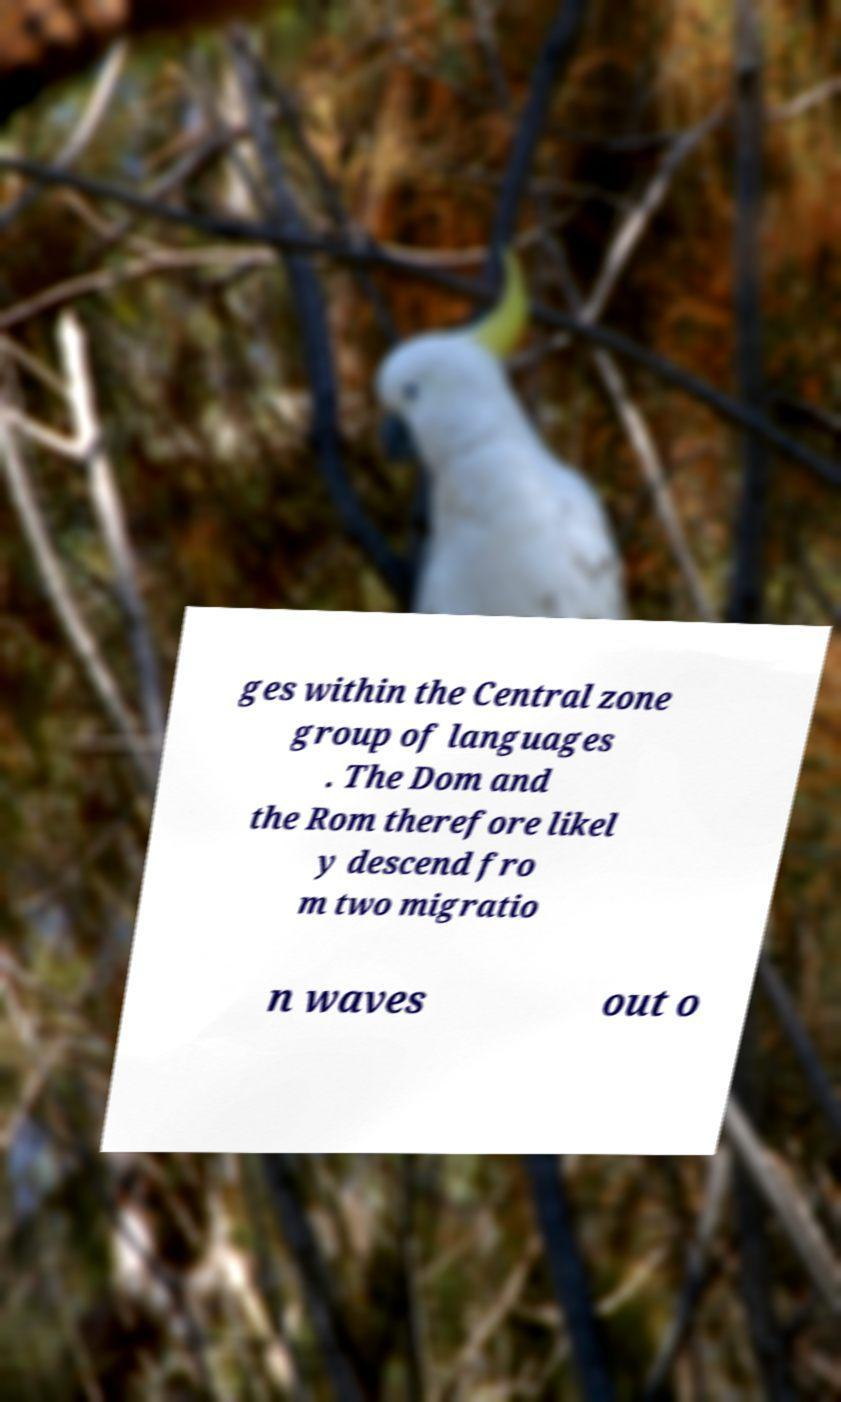Can you read and provide the text displayed in the image?This photo seems to have some interesting text. Can you extract and type it out for me? ges within the Central zone group of languages . The Dom and the Rom therefore likel y descend fro m two migratio n waves out o 